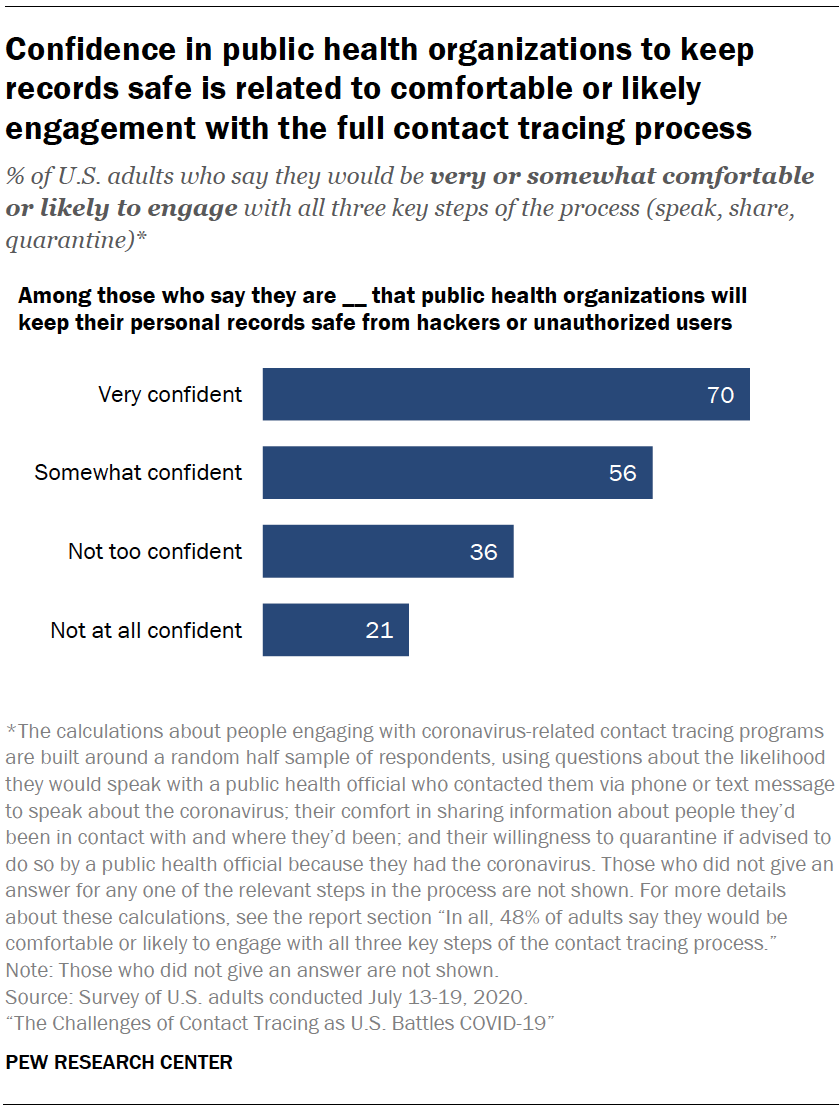Draw attention to some important aspects in this diagram. The value of the bar who said they were very confident for the question is 70. The ratio between not at all confident and very confident is 0.923611111... 